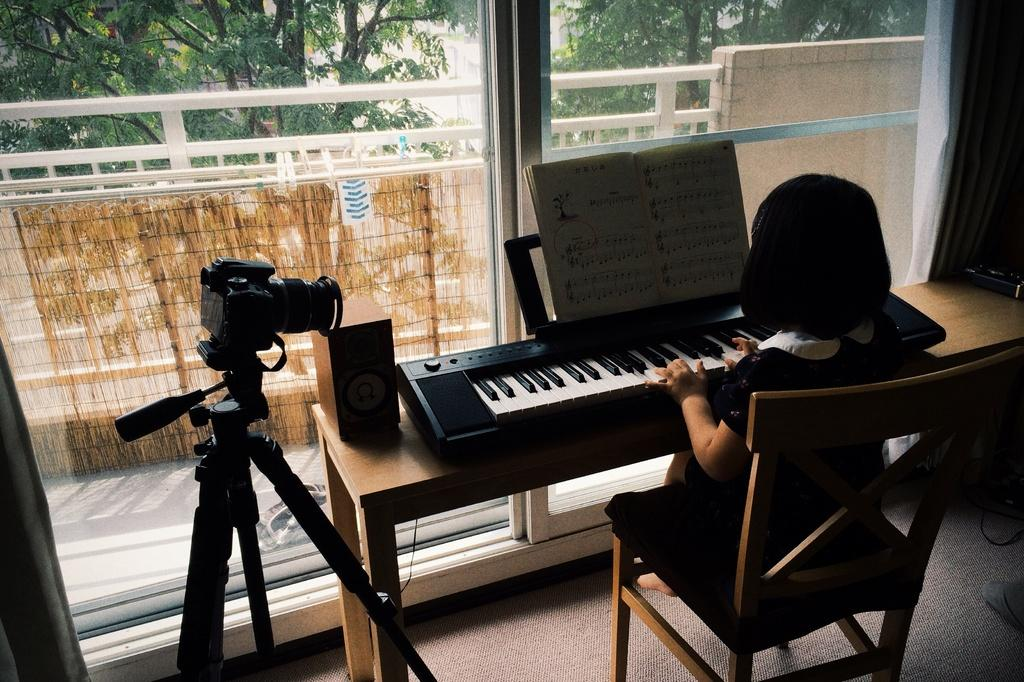Who is the main subject in the image? There is a girl in the image. What is the girl doing in the image? The girl is sitting on a chair and playing a piano. What other objects can be seen in the image? There is a table and a camera in the image. What is visible in the background of the image? There are trees in the background of the image. What type of thunder can be heard in the image? There is no thunder present in the image; it is a still photograph. Who is the owner of the piano in the image? The facts provided do not mention the ownership of the piano, so it cannot be determined from the image. 